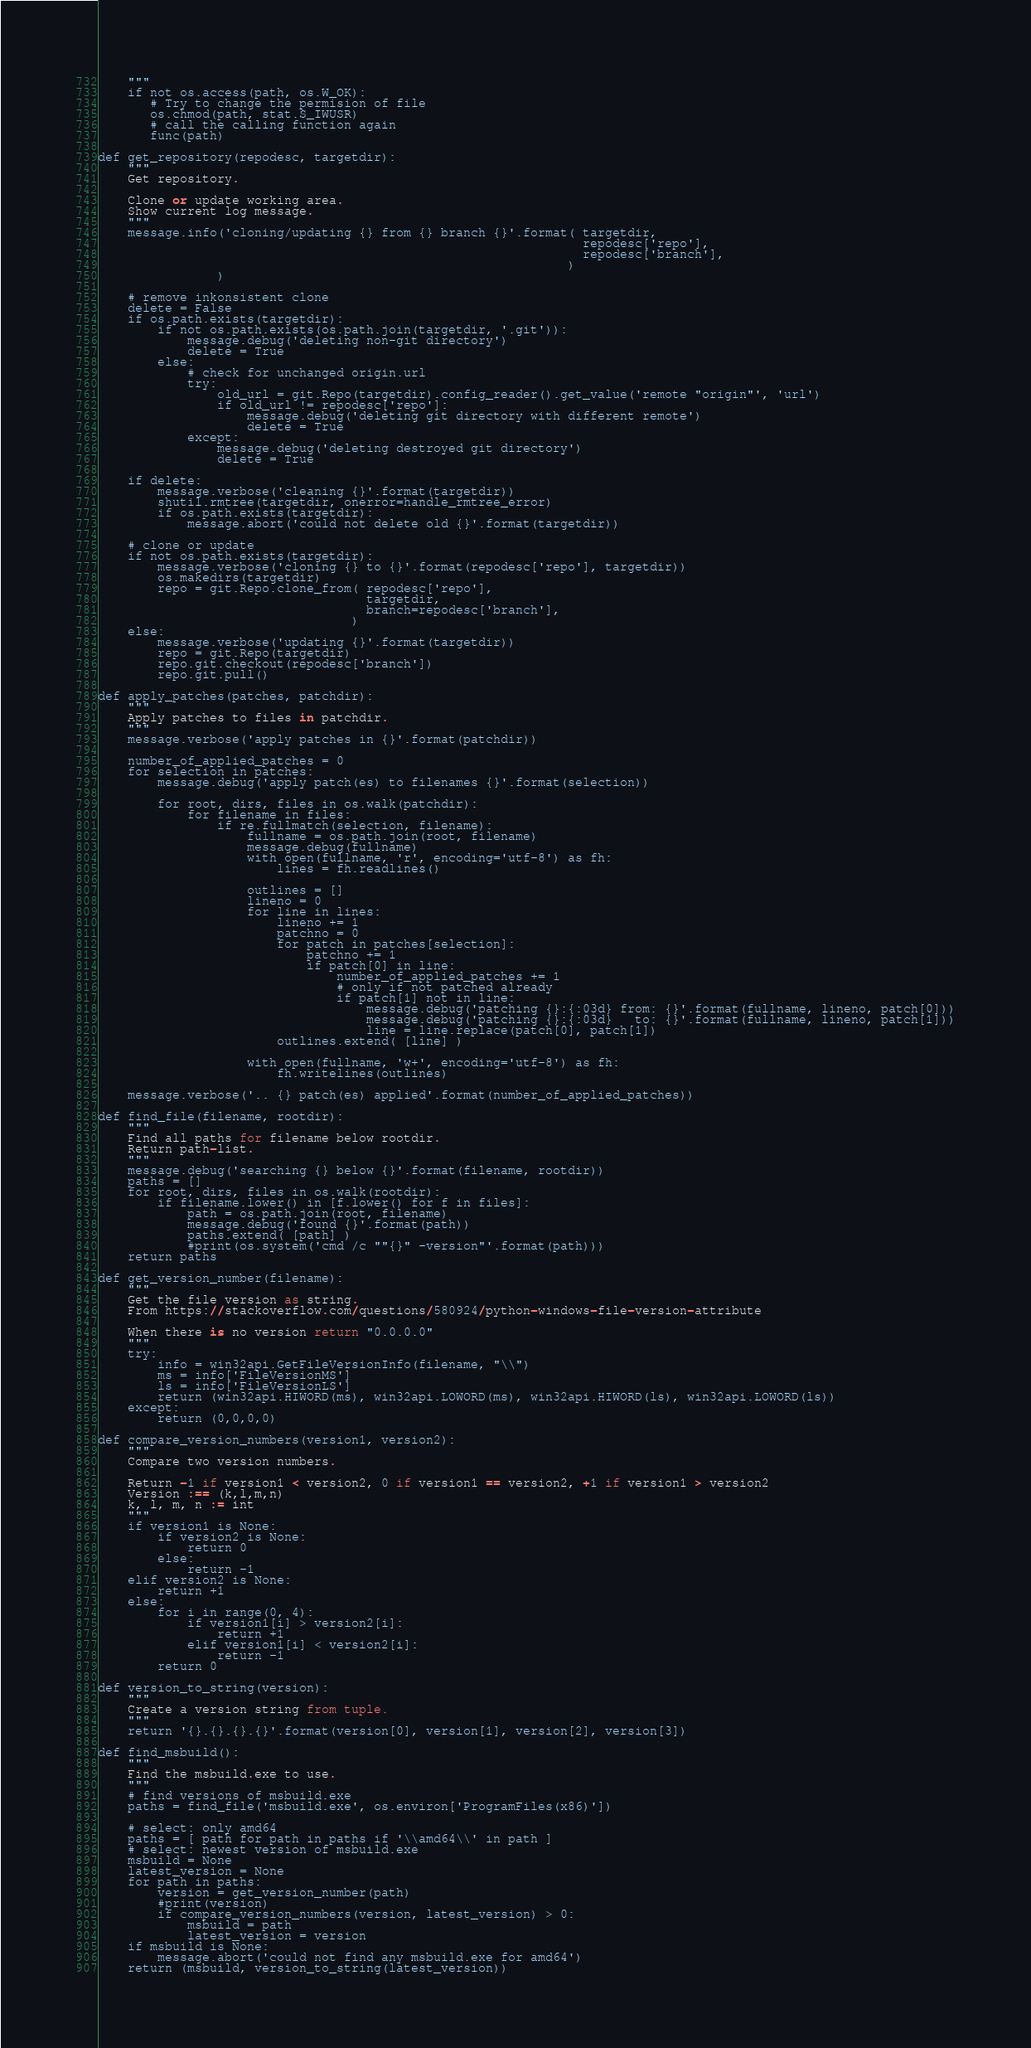<code> <loc_0><loc_0><loc_500><loc_500><_Python_>    """
    if not os.access(path, os.W_OK):
       # Try to change the permision of file
       os.chmod(path, stat.S_IWUSR)
       # call the calling function again
       func(path)

def get_repository(repodesc, targetdir):
    """
    Get repository.

    Clone or update working area.
    Show current log message.
    """
    message.info('cloning/updating {} from {} branch {}'.format( targetdir,
                                                                 repodesc['repo'],
                                                                 repodesc['branch'],
                                                               )
                )

    # remove inkonsistent clone
    delete = False
    if os.path.exists(targetdir):
        if not os.path.exists(os.path.join(targetdir, '.git')):
            message.debug('deleting non-git directory')
            delete = True
        else:
            # check for unchanged origin.url
            try:
                old_url = git.Repo(targetdir).config_reader().get_value('remote "origin"', 'url')
                if old_url != repodesc['repo']:
                    message.debug('deleting git directory with different remote')
                    delete = True
            except:
                message.debug('deleting destroyed git directory')
                delete = True

    if delete:
        message.verbose('cleaning {}'.format(targetdir))
        shutil.rmtree(targetdir, onerror=handle_rmtree_error)
        if os.path.exists(targetdir):
            message.abort('could not delete old {}'.format(targetdir))

    # clone or update
    if not os.path.exists(targetdir):
        message.verbose('cloning {} to {}'.format(repodesc['repo'], targetdir))
        os.makedirs(targetdir)
        repo = git.Repo.clone_from( repodesc['repo'],
                                    targetdir,
                                    branch=repodesc['branch'],
                                  )
    else:
        message.verbose('updating {}'.format(targetdir))
        repo = git.Repo(targetdir)
        repo.git.checkout(repodesc['branch'])
        repo.git.pull()

def apply_patches(patches, patchdir):
    """
    Apply patches to files in patchdir.
    """
    message.verbose('apply patches in {}'.format(patchdir))

    number_of_applied_patches = 0
    for selection in patches:
        message.debug('apply patch(es) to filenames {}'.format(selection))

        for root, dirs, files in os.walk(patchdir):
            for filename in files:
                if re.fullmatch(selection, filename):
                    fullname = os.path.join(root, filename)
                    message.debug(fullname)
                    with open(fullname, 'r', encoding='utf-8') as fh:
                        lines = fh.readlines()

                    outlines = []
                    lineno = 0
                    for line in lines:
                        lineno += 1
                        patchno = 0
                        for patch in patches[selection]:
                            patchno += 1
                            if patch[0] in line:
                                number_of_applied_patches += 1
                                # only if not patched already
                                if patch[1] not in line:
                                    message.debug('patching {}:{:03d} from: {}'.format(fullname, lineno, patch[0]))
                                    message.debug('patching {}:{:03d}   to: {}'.format(fullname, lineno, patch[1]))
                                    line = line.replace(patch[0], patch[1])
                        outlines.extend( [line] )

                    with open(fullname, 'w+', encoding='utf-8') as fh:
                        fh.writelines(outlines)

    message.verbose('.. {} patch(es) applied'.format(number_of_applied_patches))

def find_file(filename, rootdir):
    """
    Find all paths for filename below rootdir.
    Return path-list.
    """
    message.debug('searching {} below {}'.format(filename, rootdir))
    paths = []
    for root, dirs, files in os.walk(rootdir):
        if filename.lower() in [f.lower() for f in files]:
            path = os.path.join(root, filename)
            message.debug('found {}'.format(path))
            paths.extend( [path] )
            #print(os.system('cmd /c ""{}" -version"'.format(path)))
    return paths

def get_version_number(filename):
    """
    Get the file version as string.
    From https://stackoverflow.com/questions/580924/python-windows-file-version-attribute

    When there is no version return "0.0.0.0"
    """
    try:
        info = win32api.GetFileVersionInfo(filename, "\\")
        ms = info['FileVersionMS']
        ls = info['FileVersionLS']
        return (win32api.HIWORD(ms), win32api.LOWORD(ms), win32api.HIWORD(ls), win32api.LOWORD(ls))
    except:
        return (0,0,0,0)

def compare_version_numbers(version1, version2):
    """
    Compare two version numbers.

    Return -1 if version1 < version2, 0 if version1 == version2, +1 if version1 > version2
    Version :== (k,l,m,n)
    k, l, m, n := int
    """
    if version1 is None:
        if version2 is None:
            return 0
        else:
            return -1
    elif version2 is None:
        return +1
    else:
        for i in range(0, 4):
            if version1[i] > version2[i]:
                return +1
            elif version1[i] < version2[i]:
                return -1
        return 0

def version_to_string(version):
    """
    Create a version string from tuple.
    """
    return '{}.{}.{}.{}'.format(version[0], version[1], version[2], version[3])

def find_msbuild():
    """
    Find the msbuild.exe to use.
    """
    # find versions of msbuild.exe
    paths = find_file('msbuild.exe', os.environ['ProgramFiles(x86)'])

    # select: only amd64
    paths = [ path for path in paths if '\\amd64\\' in path ]
    # select: newest version of msbuild.exe
    msbuild = None
    latest_version = None
    for path in paths:
        version = get_version_number(path)
        #print(version)
        if compare_version_numbers(version, latest_version) > 0:
            msbuild = path
            latest_version = version
    if msbuild is None:
        message.abort('could not find any msbuild.exe for amd64')
    return (msbuild, version_to_string(latest_version))
</code> 